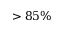Convert formula to latex. <formula><loc_0><loc_0><loc_500><loc_500>> 8 5 \%</formula> 